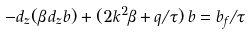<formula> <loc_0><loc_0><loc_500><loc_500>- d _ { z } ( \beta \, d _ { z } b ) + ( 2 k ^ { 2 } \beta + q / \tau ) \, b = b _ { f } / \tau</formula> 